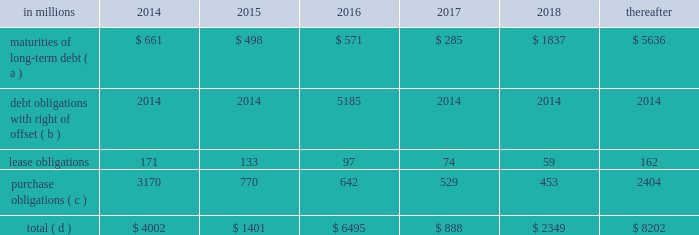Average cost of debt from 7.1% ( 7.1 % ) to an effective rate of 6.9% ( 6.9 % ) .
The inclusion of the offsetting interest income from short-term investments reduced this effective rate to 6.26% ( 6.26 % ) .
Other financing activities during 2011 included the issuance of approximately 0.3 million shares of treasury stock for various incentive plans and the acquisition of 1.0 million shares of treasury stock primarily related to restricted stock withholding taxes .
Payments of restricted stock withholding taxes totaled $ 30 million .
Off-balance sheet variable interest entities information concerning off-balance sheet variable interest entities is set forth in note 12 variable interest entities and preferred securities of subsidiaries on pages 72 through 75 of item 8 .
Financial statements and supplementary data for discussion .
Liquidity and capital resources outlook for 2014 capital expenditures and long-term debt international paper expects to be able to meet projected capital expenditures , service existing debt and meet working capital and dividend requirements during 2014 through current cash balances and cash from operations .
Additionally , the company has existing credit facilities totaling $ 2.0 billion .
The company was in compliance with all its debt covenants at december 31 , 2013 .
The company 2019s financial covenants require the maintenance of a minimum net worth of $ 9 billion and a total debt-to- capital ratio of less than 60% ( 60 % ) .
Net worth is defined as the sum of common stock , paid-in capital and retained earnings , less treasury stock plus any cumulative goodwill impairment charges .
The calculation also excludes accumulated other comprehensive income/ loss and nonrecourse financial liabilities of special purpose entities .
The total debt-to-capital ratio is defined as total debt divided by the sum of total debt plus net worth .
At december 31 , 2013 , international paper 2019s net worth was $ 15.1 billion , and the total-debt- to-capital ratio was 39% ( 39 % ) .
The company will continue to rely upon debt and capital markets for the majority of any necessary long-term funding not provided by operating cash flows .
Funding decisions will be guided by our capital structure planning objectives .
The primary goals of the company 2019s capital structure planning are to maximize financial flexibility and preserve liquidity while reducing interest expense .
The majority of international paper 2019s debt is accessed through global public capital markets where we have a wide base of investors .
Maintaining an investment grade credit rating is an important element of international paper 2019s financing strategy .
At december 31 , 2013 , the company held long-term credit ratings of bbb ( stable outlook ) and baa3 ( stable outlook ) by s&p and moody 2019s , respectively .
Contractual obligations for future payments under existing debt and lease commitments and purchase obligations at december 31 , 2013 , were as follows: .
( a ) total debt includes scheduled principal payments only .
( b ) represents debt obligations borrowed from non-consolidated variable interest entities for which international paper has , and intends to effect , a legal right to offset these obligations with investments held in the entities .
Accordingly , in its consolidated balance sheet at december 31 , 2013 , international paper has offset approximately $ 5.2 billion of interests in the entities against this $ 5.2 billion of debt obligations held by the entities ( see note 12 variable interest entities and preferred securities of subsidiaries on pages 72 through 75 in item 8 .
Financial statements and supplementary data ) .
( c ) includes $ 3.3 billion relating to fiber supply agreements entered into at the time of the 2006 transformation plan forestland sales and in conjunction with the 2008 acquisition of weyerhaeuser company 2019s containerboard , packaging and recycling business .
( d ) not included in the above table due to the uncertainty as to the amount and timing of the payment are unrecognized tax benefits of approximately $ 146 million .
We consider the undistributed earnings of our foreign subsidiaries as of december 31 , 2013 , to be indefinitely reinvested and , accordingly , no u.s .
Income taxes have been provided thereon .
As of december 31 , 2013 , the amount of cash associated with indefinitely reinvested foreign earnings was approximately $ 900 million .
We do not anticipate the need to repatriate funds to the united states to satisfy domestic liquidity needs arising in the ordinary course of business , including liquidity needs associated with our domestic debt service requirements .
Pension obligations and funding at december 31 , 2013 , the projected benefit obligation for the company 2019s u.s .
Defined benefit plans determined under u.s .
Gaap was approximately $ 2.2 billion higher than the fair value of plan assets .
Approximately $ 1.8 billion of this amount relates to plans that are subject to minimum funding requirements .
Under current irs funding rules , the calculation of minimum funding requirements differs from the calculation of the present value of plan benefits ( the projected benefit obligation ) for accounting purposes .
In december 2008 , the worker , retiree and employer recovery act of 2008 ( wera ) was passed by the u.s .
Congress which provided for pension funding relief and technical corrections .
Funding .
In 2013 what was the percentage of the contractual obligations for future payments for long term debt due in 2014? 
Computations: (661 / 4002)
Answer: 0.16517. 